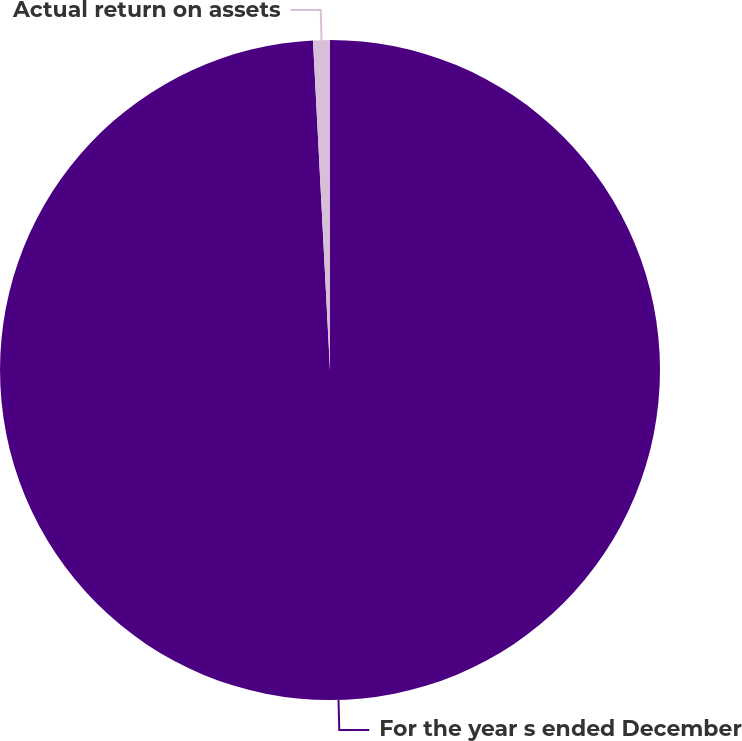<chart> <loc_0><loc_0><loc_500><loc_500><pie_chart><fcel>For the year s ended December<fcel>Actual return on assets<nl><fcel>99.18%<fcel>0.82%<nl></chart> 